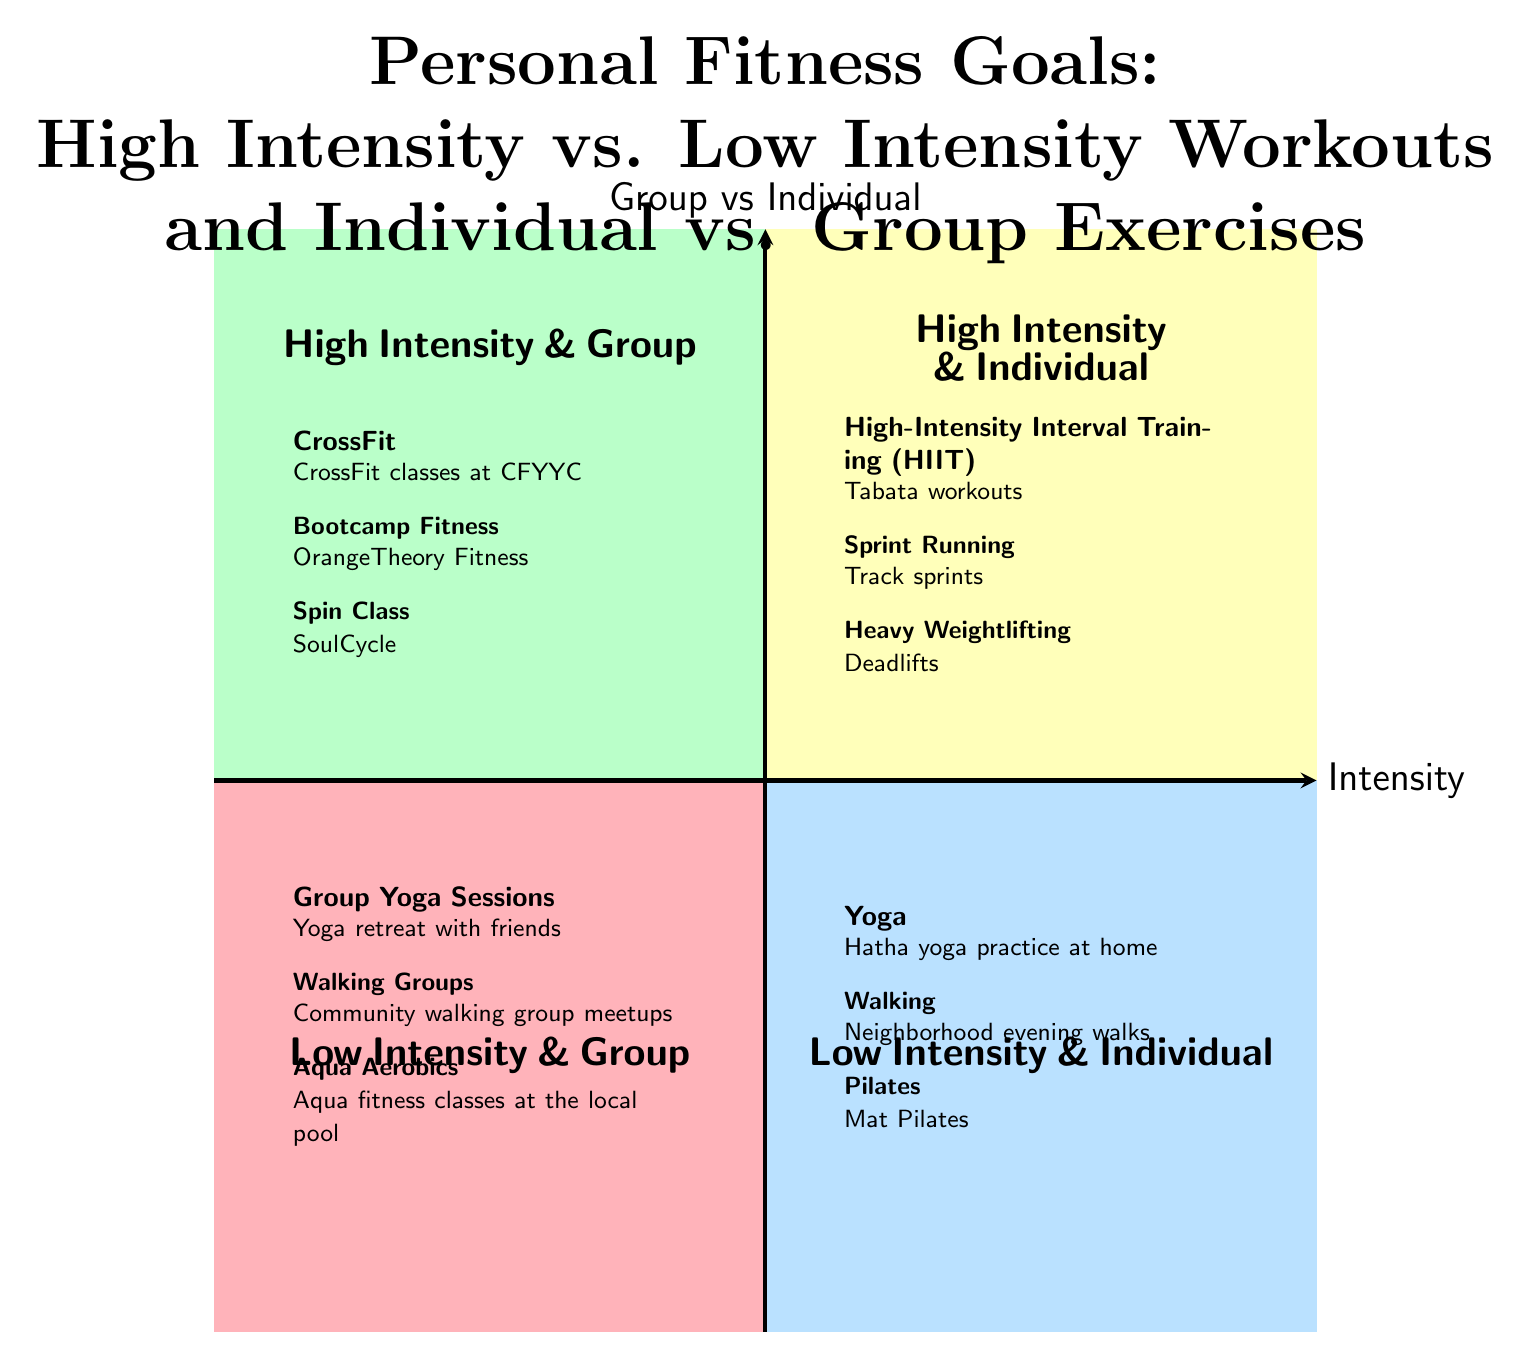What activities are listed in the High Intensity & Individual quadrant? The High Intensity & Individual quadrant contains three activities: High-Intensity Interval Training (HIIT), Sprint Running, and Heavy Weightlifting.
Answer: High-Intensity Interval Training (HIIT), Sprint Running, Heavy Weightlifting How many activities are in the Low Intensity & Group quadrant? In the Low Intensity & Group quadrant, there are three activities: Group Yoga Sessions, Walking Groups, and Aqua Aerobics. Thus, the total number of activities is three.
Answer: 3 Which quadrant has activities focused on group workouts? The quadrants with activities focused on group workouts are High Intensity & Group and Low Intensity & Group, as both of these quadrants contain activities that are designed for group exercise.
Answer: High Intensity & Group, Low Intensity & Group What is an example of an activity in the Low Intensity & Individual quadrant? The Low Intensity & Individual quadrant includes activities such as Yoga, Walking, and Pilates. For instance, Yoga involves practices like Hatha yoga at home.
Answer: Yoga Which type of workout is associated with CrossFit? CrossFit is categorized under High Intensity & Group workouts, hence it is associated with high intensity, specifically in a group setting.
Answer: High Intensity & Group How many quadrants are included in the diagram? The diagram contains four quadrants in total, which are High Intensity & Individual, High Intensity & Group, Low Intensity & Individual, and Low Intensity & Group.
Answer: 4 What is the relationship between Heavy Weightlifting and the workout intensity? Heavy Weightlifting is located in the High Intensity & Individual quadrant, indicating that it is a high intensity workout performed individually.
Answer: High Intensity In which quadrant would you find Aqua Aerobics? Aqua Aerobics is listed in the Low Intensity & Group quadrant, meaning it is a low intensity exercise conducted in a group setting.
Answer: Low Intensity & Group 